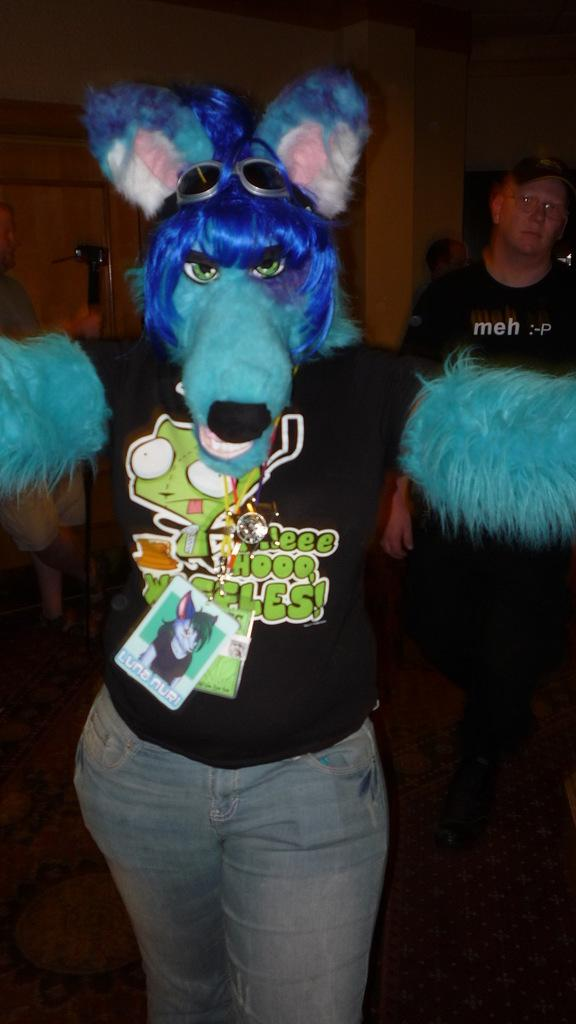What is the main subject of the image? There is a person standing in the image. What is the person wearing on their head? The person is wearing a head mask. What else is the person wearing? The person is wearing an ID card. Are there any other people in the image? Yes, there is another man standing in the image. What type of development can be seen in the background of the image? There is no development visible in the background of the image; it only features the two people. What kind of ray is being used by the person in the image? There is no ray present in the image; the person is wearing a head mask and an ID card. 